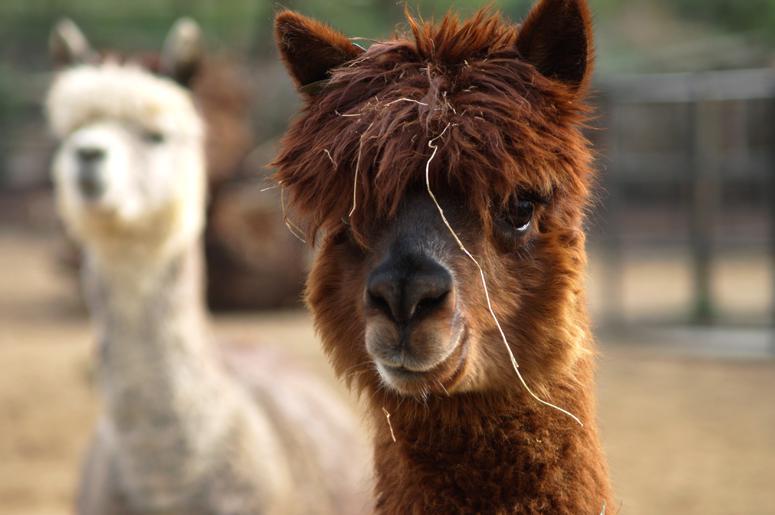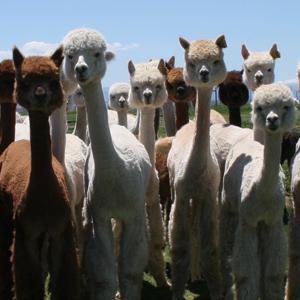The first image is the image on the left, the second image is the image on the right. Given the left and right images, does the statement "There is a young llama in both images." hold true? Answer yes or no. No. The first image is the image on the left, the second image is the image on the right. For the images displayed, is the sentence "Every llama appears to be looking directly at the viewer (i.e. facing the camera)." factually correct? Answer yes or no. Yes. 